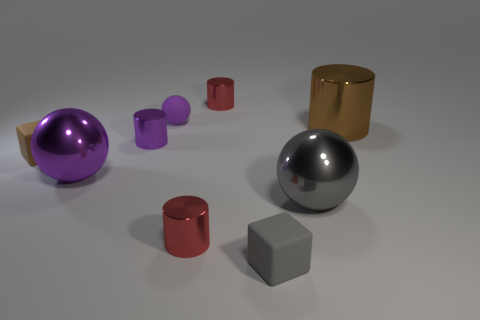Subtract all gray balls. How many balls are left? 2 Subtract all small balls. How many balls are left? 2 Subtract 1 gray blocks. How many objects are left? 8 Subtract all cylinders. How many objects are left? 5 Subtract 1 cylinders. How many cylinders are left? 3 Subtract all yellow spheres. Subtract all green cubes. How many spheres are left? 3 Subtract all cyan balls. How many gray blocks are left? 1 Subtract all purple objects. Subtract all big cyan metal blocks. How many objects are left? 6 Add 7 purple spheres. How many purple spheres are left? 9 Add 3 metallic things. How many metallic things exist? 9 